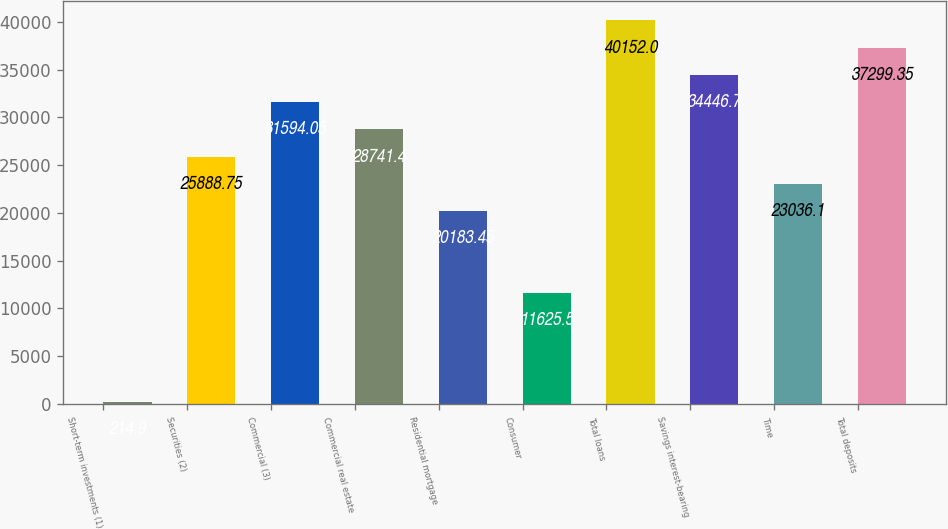Convert chart. <chart><loc_0><loc_0><loc_500><loc_500><bar_chart><fcel>Short-term investments (1)<fcel>Securities (2)<fcel>Commercial (3)<fcel>Commercial real estate<fcel>Residential mortgage<fcel>Consumer<fcel>Total loans<fcel>Savings interest-bearing<fcel>Time<fcel>Total deposits<nl><fcel>214.9<fcel>25888.8<fcel>31594<fcel>28741.4<fcel>20183.5<fcel>11625.5<fcel>40152<fcel>34446.7<fcel>23036.1<fcel>37299.3<nl></chart> 